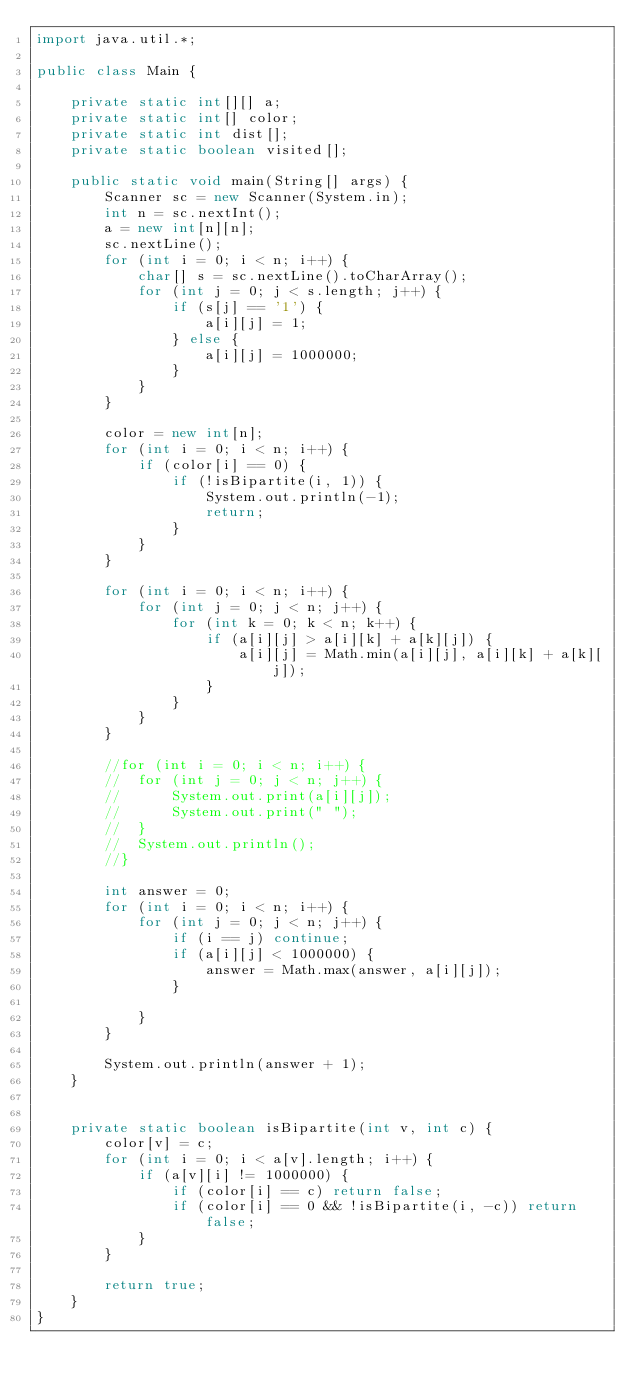Convert code to text. <code><loc_0><loc_0><loc_500><loc_500><_Java_>import java.util.*;

public class Main {

	private static int[][] a;
	private static int[] color;
	private static int dist[];
	private static boolean visited[];

	public static void main(String[] args) {
		Scanner sc = new Scanner(System.in);
		int n = sc.nextInt();
		a = new int[n][n];
		sc.nextLine();
		for (int i = 0; i < n; i++) {
			char[] s = sc.nextLine().toCharArray();
			for (int j = 0; j < s.length; j++) {
				if (s[j] == '1') {
					a[i][j] = 1;
				} else {
					a[i][j] = 1000000;
				}
			}
		}

		color = new int[n];
		for (int i = 0; i < n; i++) {
			if (color[i] == 0) {
				if (!isBipartite(i, 1)) {
					System.out.println(-1);
					return;
				}
			}
		}

		for (int i = 0; i < n; i++) {
			for (int j = 0; j < n; j++) {
				for (int k = 0; k < n; k++) {
					if (a[i][j] > a[i][k] + a[k][j]) {
						a[i][j] = Math.min(a[i][j], a[i][k] + a[k][j]);
					}
				}
			}
		}

		//for (int i = 0; i < n; i++) {
		//	for (int j = 0; j < n; j++) {
		//		System.out.print(a[i][j]);
		//		System.out.print(" ");
		//	}
		//	System.out.println();
		//}

		int answer = 0;
		for (int i = 0; i < n; i++) {
			for (int j = 0; j < n; j++) {
				if (i == j) continue;
				if (a[i][j] < 1000000) {
					answer = Math.max(answer, a[i][j]);
				}

			}
		}

		System.out.println(answer + 1);
	}


	private static boolean isBipartite(int v, int c) {
		color[v] = c;
		for (int i = 0; i < a[v].length; i++) {
			if (a[v][i] != 1000000) {
				if (color[i] == c) return false;
				if (color[i] == 0 && !isBipartite(i, -c)) return false;
			}
		}

		return true;
	}
}
</code> 